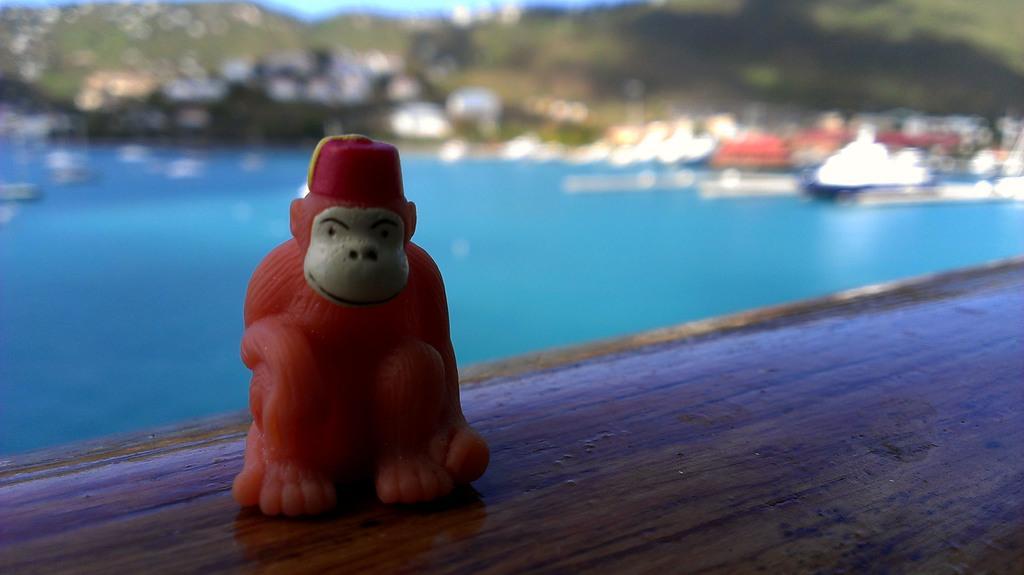How would you summarize this image in a sentence or two? This picture contains a toy monkey which is in red color is placed on the brown color table. Behind that, we see water and boats. There are many trees in the background and it is blurred in the background. 